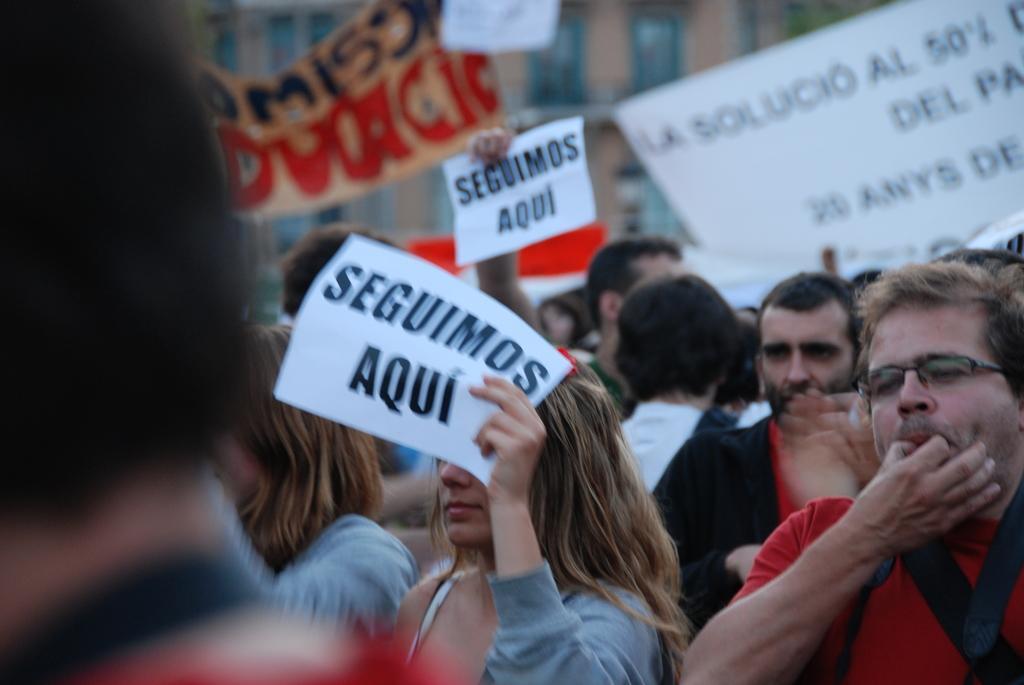Could you give a brief overview of what you see in this image? In this picture there is a group of people in the image who is on the protest and holding the papers in the hand. On the right side we can see a man wearing red color t-shirt and he is whistling. 